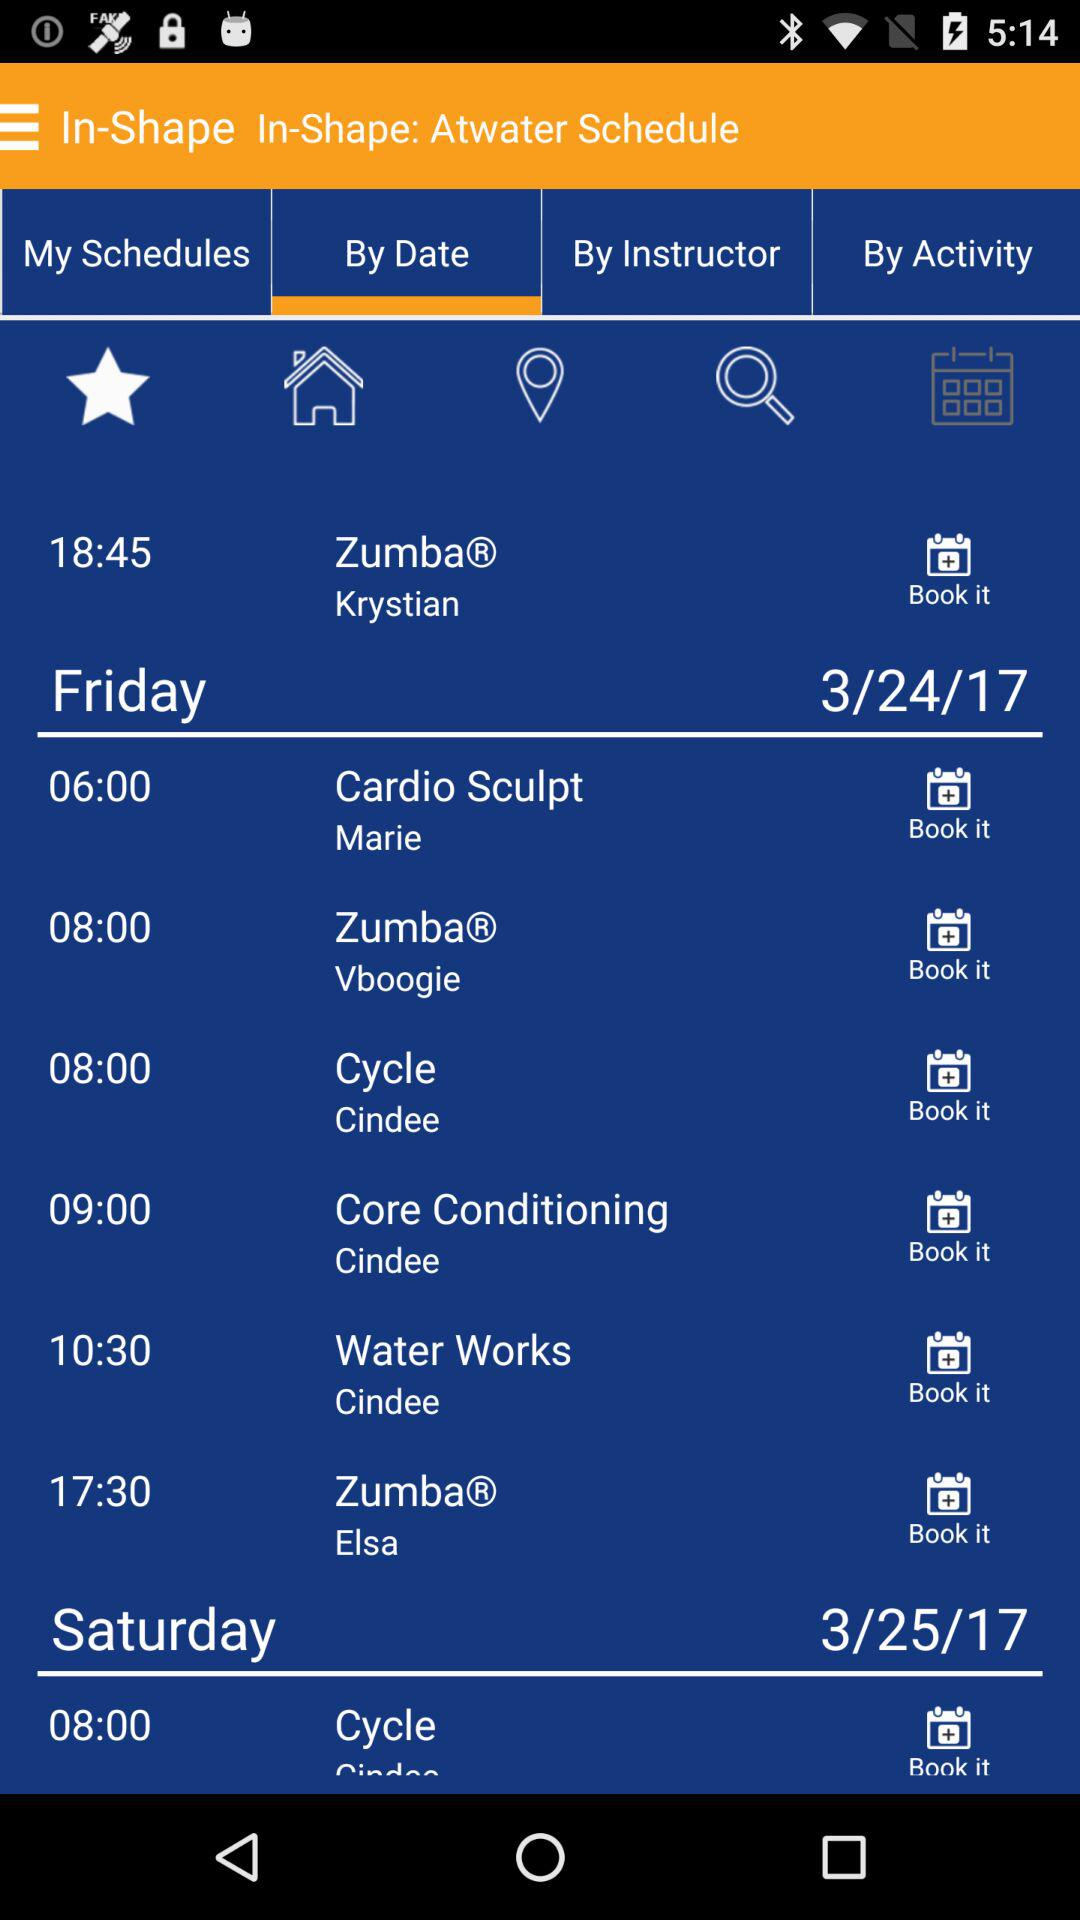How many classes are there on Friday?
Answer the question using a single word or phrase. 6 